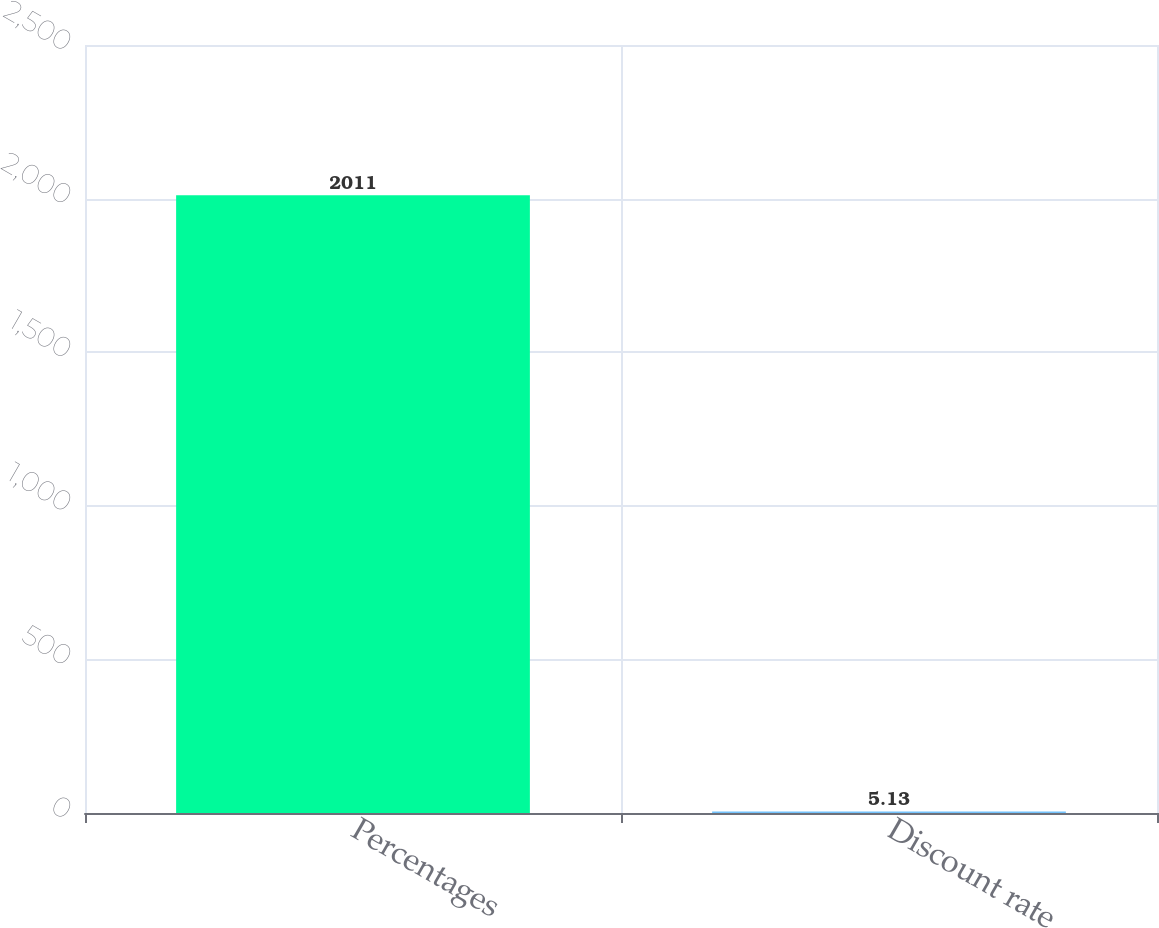<chart> <loc_0><loc_0><loc_500><loc_500><bar_chart><fcel>Percentages<fcel>Discount rate<nl><fcel>2011<fcel>5.13<nl></chart> 